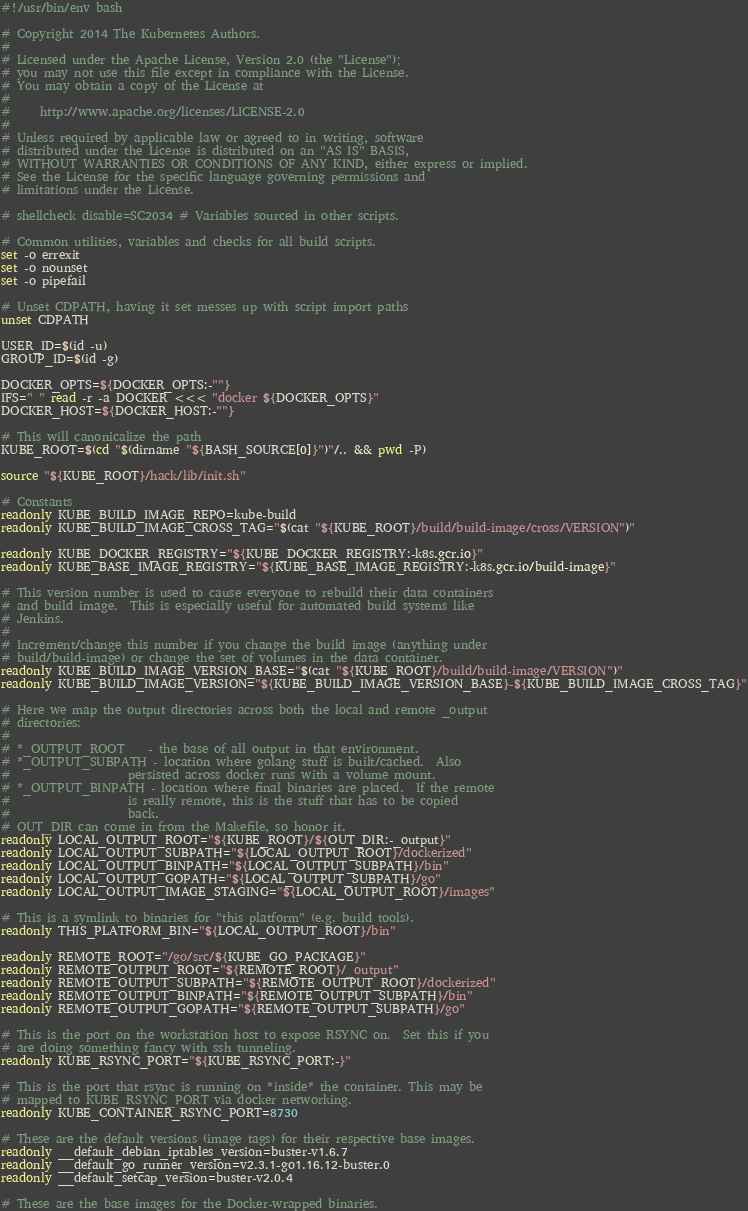Convert code to text. <code><loc_0><loc_0><loc_500><loc_500><_Bash_>#!/usr/bin/env bash

# Copyright 2014 The Kubernetes Authors.
#
# Licensed under the Apache License, Version 2.0 (the "License");
# you may not use this file except in compliance with the License.
# You may obtain a copy of the License at
#
#     http://www.apache.org/licenses/LICENSE-2.0
#
# Unless required by applicable law or agreed to in writing, software
# distributed under the License is distributed on an "AS IS" BASIS,
# WITHOUT WARRANTIES OR CONDITIONS OF ANY KIND, either express or implied.
# See the License for the specific language governing permissions and
# limitations under the License.

# shellcheck disable=SC2034 # Variables sourced in other scripts.

# Common utilities, variables and checks for all build scripts.
set -o errexit
set -o nounset
set -o pipefail

# Unset CDPATH, having it set messes up with script import paths
unset CDPATH

USER_ID=$(id -u)
GROUP_ID=$(id -g)

DOCKER_OPTS=${DOCKER_OPTS:-""}
IFS=" " read -r -a DOCKER <<< "docker ${DOCKER_OPTS}"
DOCKER_HOST=${DOCKER_HOST:-""}

# This will canonicalize the path
KUBE_ROOT=$(cd "$(dirname "${BASH_SOURCE[0]}")"/.. && pwd -P)

source "${KUBE_ROOT}/hack/lib/init.sh"

# Constants
readonly KUBE_BUILD_IMAGE_REPO=kube-build
readonly KUBE_BUILD_IMAGE_CROSS_TAG="$(cat "${KUBE_ROOT}/build/build-image/cross/VERSION")"

readonly KUBE_DOCKER_REGISTRY="${KUBE_DOCKER_REGISTRY:-k8s.gcr.io}"
readonly KUBE_BASE_IMAGE_REGISTRY="${KUBE_BASE_IMAGE_REGISTRY:-k8s.gcr.io/build-image}"

# This version number is used to cause everyone to rebuild their data containers
# and build image.  This is especially useful for automated build systems like
# Jenkins.
#
# Increment/change this number if you change the build image (anything under
# build/build-image) or change the set of volumes in the data container.
readonly KUBE_BUILD_IMAGE_VERSION_BASE="$(cat "${KUBE_ROOT}/build/build-image/VERSION")"
readonly KUBE_BUILD_IMAGE_VERSION="${KUBE_BUILD_IMAGE_VERSION_BASE}-${KUBE_BUILD_IMAGE_CROSS_TAG}"

# Here we map the output directories across both the local and remote _output
# directories:
#
# *_OUTPUT_ROOT    - the base of all output in that environment.
# *_OUTPUT_SUBPATH - location where golang stuff is built/cached.  Also
#                    persisted across docker runs with a volume mount.
# *_OUTPUT_BINPATH - location where final binaries are placed.  If the remote
#                    is really remote, this is the stuff that has to be copied
#                    back.
# OUT_DIR can come in from the Makefile, so honor it.
readonly LOCAL_OUTPUT_ROOT="${KUBE_ROOT}/${OUT_DIR:-_output}"
readonly LOCAL_OUTPUT_SUBPATH="${LOCAL_OUTPUT_ROOT}/dockerized"
readonly LOCAL_OUTPUT_BINPATH="${LOCAL_OUTPUT_SUBPATH}/bin"
readonly LOCAL_OUTPUT_GOPATH="${LOCAL_OUTPUT_SUBPATH}/go"
readonly LOCAL_OUTPUT_IMAGE_STAGING="${LOCAL_OUTPUT_ROOT}/images"

# This is a symlink to binaries for "this platform" (e.g. build tools).
readonly THIS_PLATFORM_BIN="${LOCAL_OUTPUT_ROOT}/bin"

readonly REMOTE_ROOT="/go/src/${KUBE_GO_PACKAGE}"
readonly REMOTE_OUTPUT_ROOT="${REMOTE_ROOT}/_output"
readonly REMOTE_OUTPUT_SUBPATH="${REMOTE_OUTPUT_ROOT}/dockerized"
readonly REMOTE_OUTPUT_BINPATH="${REMOTE_OUTPUT_SUBPATH}/bin"
readonly REMOTE_OUTPUT_GOPATH="${REMOTE_OUTPUT_SUBPATH}/go"

# This is the port on the workstation host to expose RSYNC on.  Set this if you
# are doing something fancy with ssh tunneling.
readonly KUBE_RSYNC_PORT="${KUBE_RSYNC_PORT:-}"

# This is the port that rsync is running on *inside* the container. This may be
# mapped to KUBE_RSYNC_PORT via docker networking.
readonly KUBE_CONTAINER_RSYNC_PORT=8730

# These are the default versions (image tags) for their respective base images.
readonly __default_debian_iptables_version=buster-v1.6.7
readonly __default_go_runner_version=v2.3.1-go1.16.12-buster.0
readonly __default_setcap_version=buster-v2.0.4

# These are the base images for the Docker-wrapped binaries.</code> 